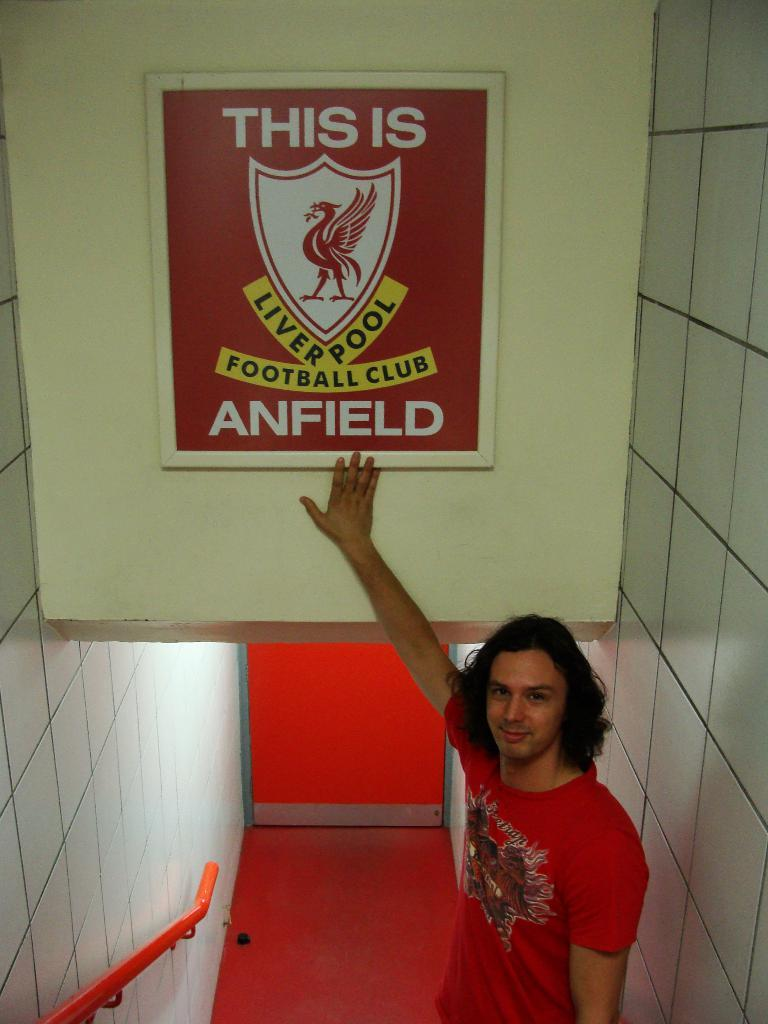Who is the main subject in the image? There is a man in the center of the image. What is the man doing in the image? The man is standing and placing his hand on a board. What is the man's facial expression in the image? The man is smiling in the image. What can be seen in the background of the image? There are walls and a railing in the background of the image. What type of leather is the horse wearing in the image? There is no horse or leather present in the image; it features a man standing and placing his hand on a board. What is the weather like in the image? The provided facts do not mention the weather, so it cannot be determined from the image. 